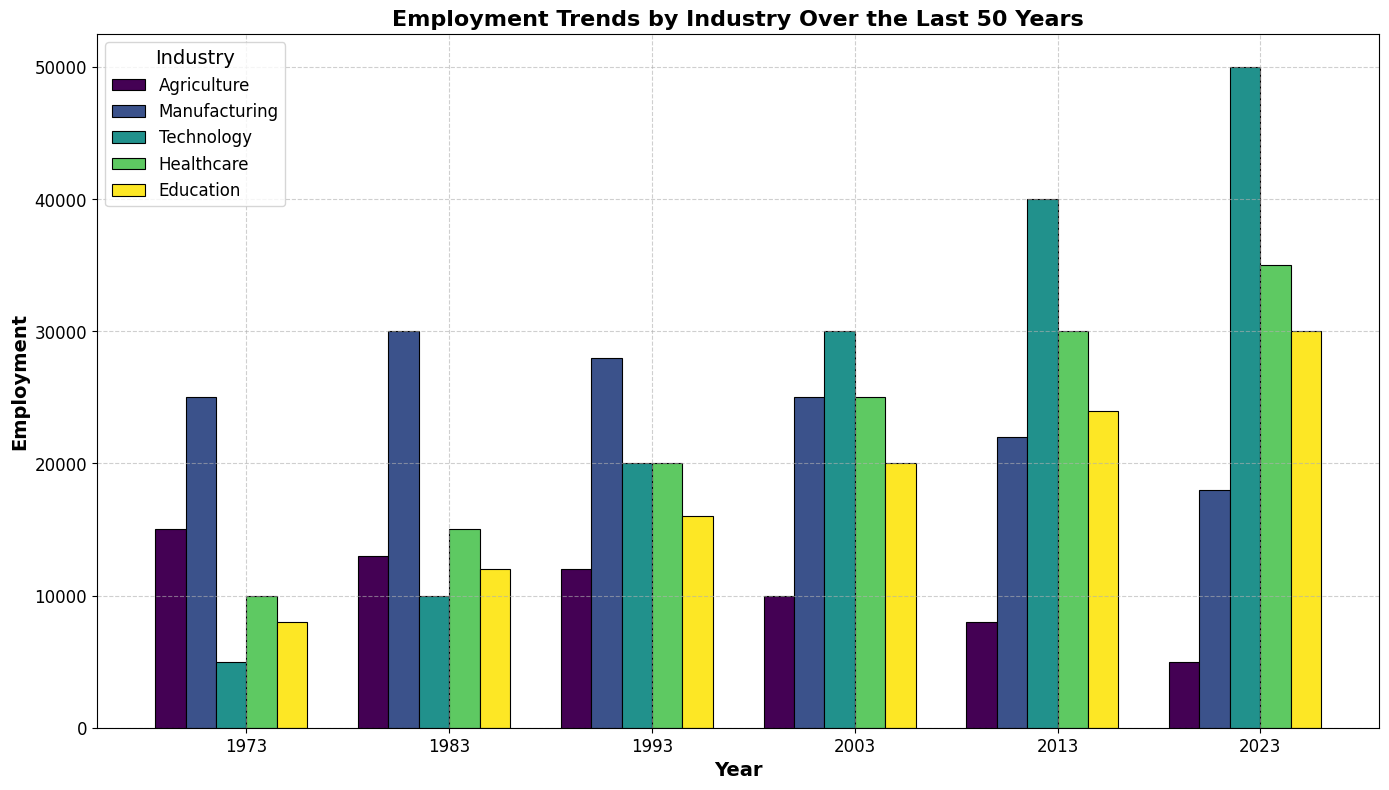What's the overall trend of employment in the Agriculture industry from 1973 to 2023? To determine the trend, observe the heights of the bars for Agriculture across different years (1973 to 2023). The bar heights decrease over this period, indicating a downward trend in employment.
Answer: Downward trend Which industry has the highest employment in 2023? Locate the bars corresponding to the year 2023 and compare their heights. The Technology industry has the tallest bar, indicating the highest employment.
Answer: Technology How has employment in the Healthcare industry changed from 2003 to 2023? Compare the heights of the Healthcare bars for 2003 and 2023. The height of the 2023 bar is greater than the 2003 bar, indicating an increase in employment.
Answer: Increased What is the difference in employment between Manufacturing and Technology industries in 2023? In 2023, identify the heights of the Manufacturing and Technology bars. Subtract the height of the Manufacturing bar from the Technology bar. Technology (50,000) - Manufacturing (18,000) = 32,000.
Answer: 32,000 Which industry has seen the most significant growth in employment over the 50 years? Observe the initial and final bar heights for each industry from 1973 to 2023. Technology shows the most significant growth, as its bar height increased the most.
Answer: Technology How does employment in Education in 2013 compare to that in 1993? Compare the heights of the Education bars for the years 2013 and 1993. The 2013 bar is taller, suggesting higher employment.
Answer: Higher in 2013 Calculate the average employment in Healthcare across all six years. Sum the employment values for Healthcare in each year and divide by the number of years: (10,000 + 15,000 + 20,000 + 25,000 + 30,000 + 35,000) / 6 = 135,000 / 6 = 22,500.
Answer: 22,500 What is the visual pattern of employment in the Manufacturing industry over the five-decade span? Observe the heights of the bars for Manufacturing from 1973 to 2023. The pattern shows an initial increase, peaking in 1983, followed by a gradual decrease.
Answer: Peak in 1983, then decrease Which industry had the smallest employment in 1973? Identify the lowest bar in 1973. The Technology industry has the smallest bar height in 1973.
Answer: Technology What can you infer about the job market in the Technology sector from 1973 to 2023? Observe the steady increase in the height of the Technology bars from 1973 to 2023, indicating consistent growth in employment in this sector over the 50 years.
Answer: Consistent growth 